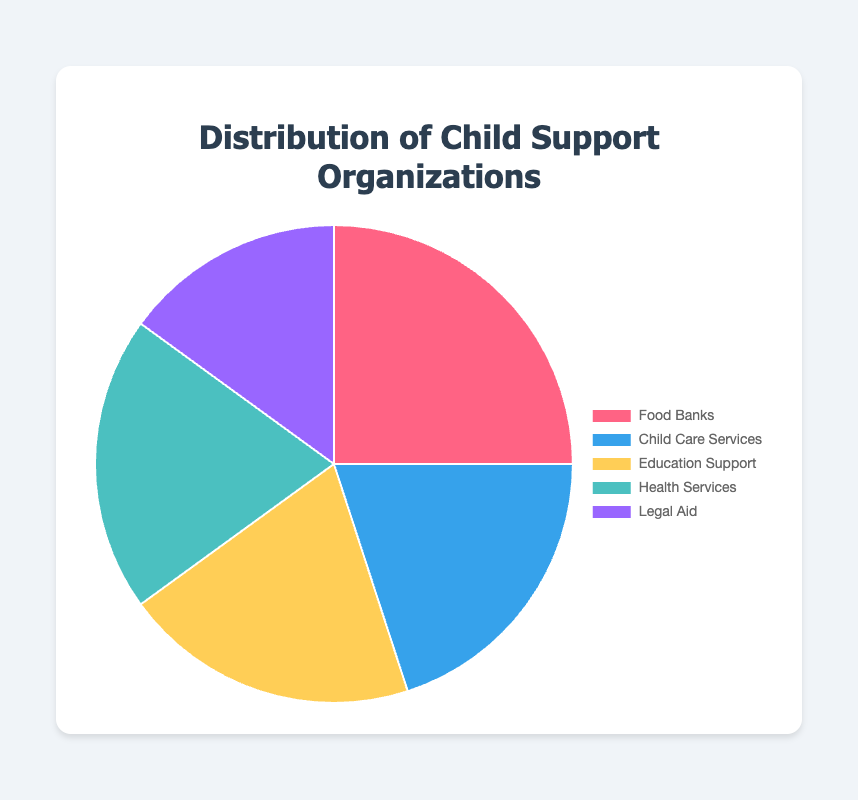Which type of child support organization has the highest percentage? By observing the pie chart, the segment representing Food Banks is the largest, indicating the highest percentage (25%).
Answer: Food Banks What is the combined percentage of Child Care Services, Education Support, and Health Services? The percentages for Child Care Services, Education Support, and Health Services are 20%, 20%, and 20%, respectively. Adding these together gives 20 + 20 + 20 = 60%.
Answer: 60% Which type of organization constitutes the smallest percentage of the pie chart? The smallest segment of the pie chart represents Legal Aid, which constitutes 15% of the total.
Answer: Legal Aid How does the percentage of Legal Aid compare to that of Health Services? Legal Aid has a percentage of 15%, while Health Services has 20%. Therefore, Legal Aid is 5% less than Health Services.
Answer: 5% less If you combine the percentages of Food Banks and Legal Aid, how does that total compare with the percentage of the remaining organizations combined? The percentage for Food Banks is 25% and for Legal Aid is 15%, together they sum up to 40%. The remaining organizations (Child Care Services, Education Support, and Health Services) sum up to 20% + 20% + 20% = 60%. Therefore, the remaining organizations combined have 20% more than the total of Food Banks and Legal Aid.
Answer: 20% more What is the visual color for the Child Care Services segment? By observing the color of the Child Care Services segment on the pie chart, it is identified as blue.
Answer: Blue How many types of organizations each make up exactly 20% of the total distribution? By examining the segments on the pie chart, Child Care Services, Education Support, and Health Services each make up exactly 20% of the total distribution.
Answer: 3 Is the sum of the percentages of the smallest and largest segments greater than 50%? The smallest segment (Legal Aid) is 15% and the largest segment (Food Banks) is 25%. Adding these together gives 15 + 25 = 40%, which is not greater than 50%.
Answer: No 